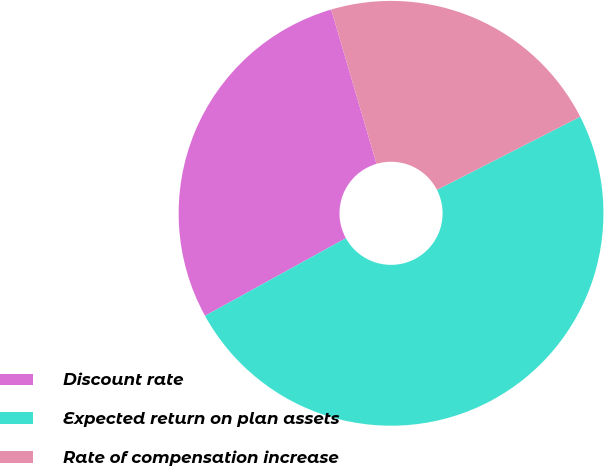Convert chart to OTSL. <chart><loc_0><loc_0><loc_500><loc_500><pie_chart><fcel>Discount rate<fcel>Expected return on plan assets<fcel>Rate of compensation increase<nl><fcel>28.47%<fcel>49.49%<fcel>22.03%<nl></chart> 